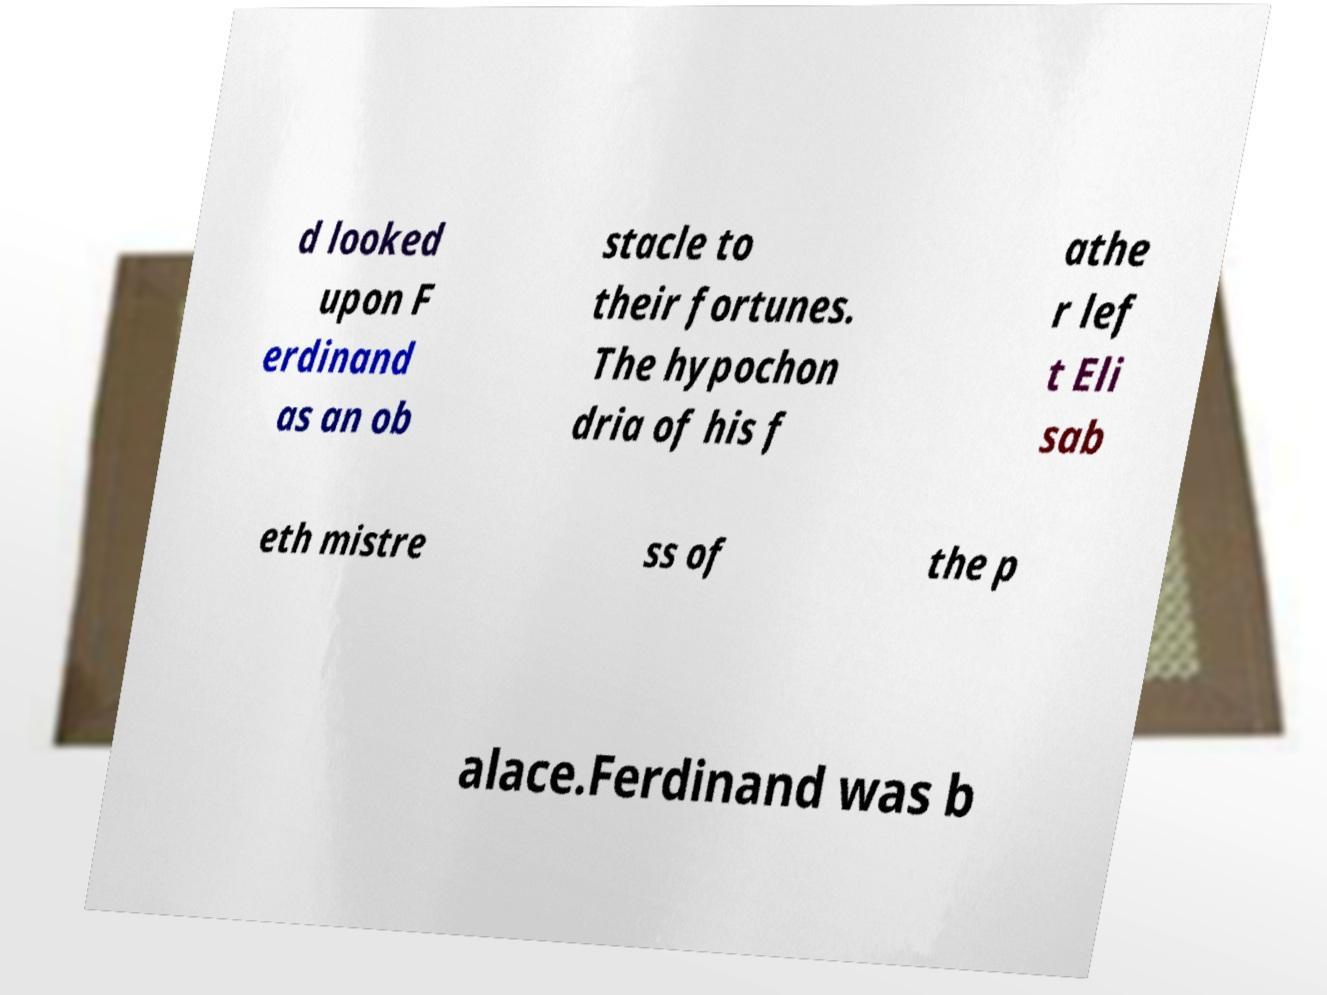For documentation purposes, I need the text within this image transcribed. Could you provide that? d looked upon F erdinand as an ob stacle to their fortunes. The hypochon dria of his f athe r lef t Eli sab eth mistre ss of the p alace.Ferdinand was b 